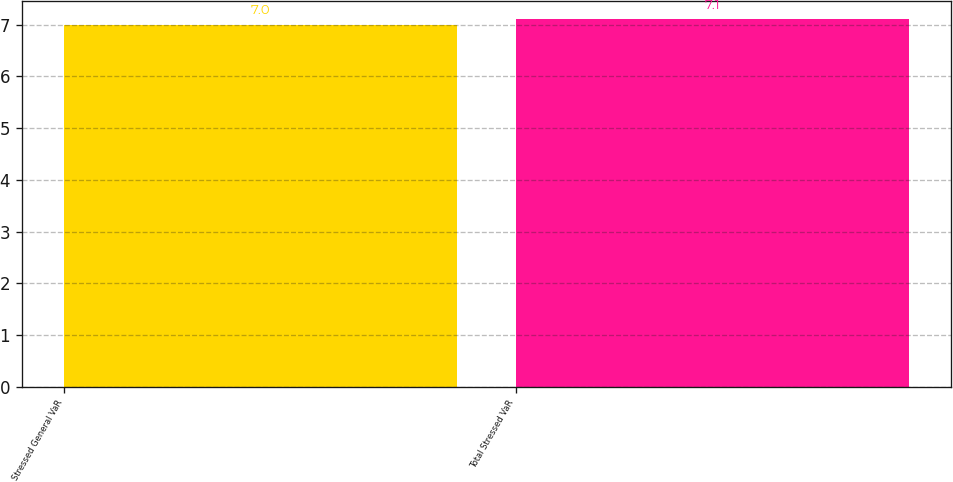Convert chart to OTSL. <chart><loc_0><loc_0><loc_500><loc_500><bar_chart><fcel>Stressed General VaR<fcel>Total Stressed VaR<nl><fcel>7<fcel>7.1<nl></chart> 